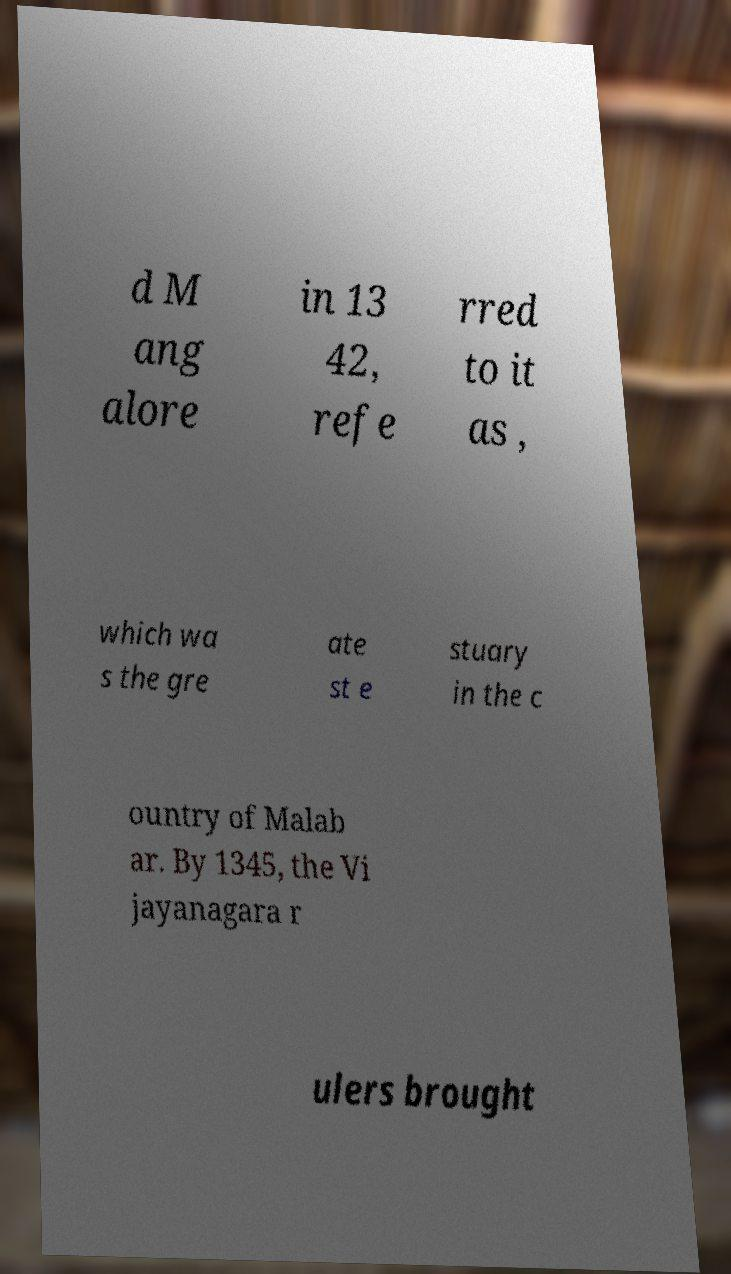There's text embedded in this image that I need extracted. Can you transcribe it verbatim? d M ang alore in 13 42, refe rred to it as , which wa s the gre ate st e stuary in the c ountry of Malab ar. By 1345, the Vi jayanagara r ulers brought 